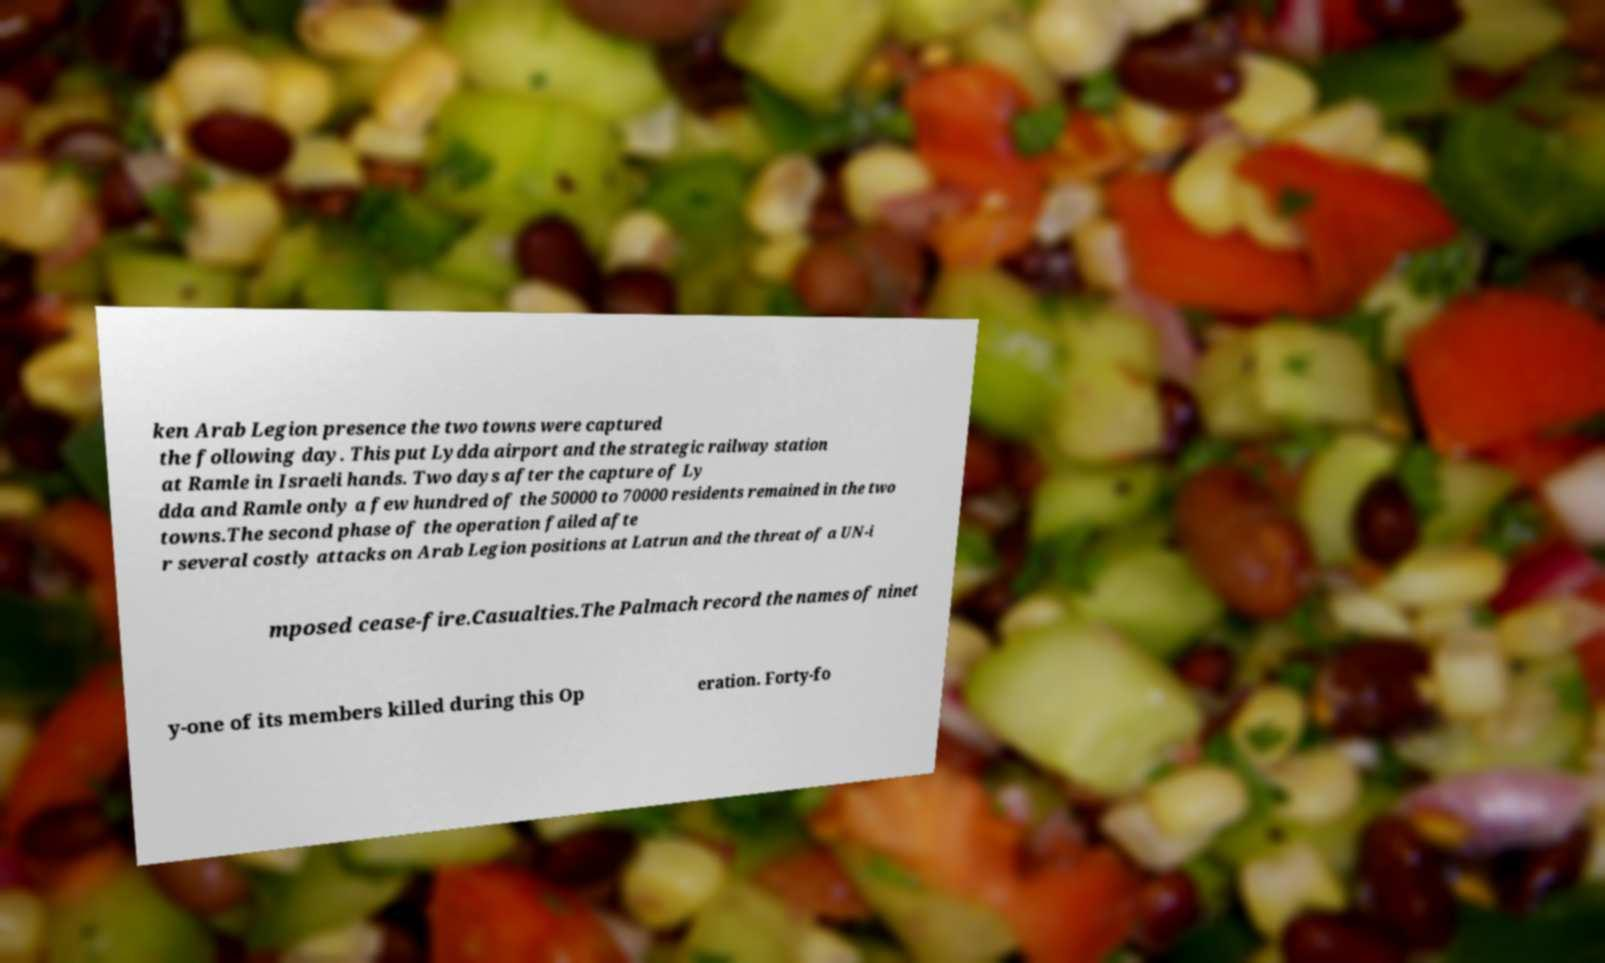There's text embedded in this image that I need extracted. Can you transcribe it verbatim? ken Arab Legion presence the two towns were captured the following day. This put Lydda airport and the strategic railway station at Ramle in Israeli hands. Two days after the capture of Ly dda and Ramle only a few hundred of the 50000 to 70000 residents remained in the two towns.The second phase of the operation failed afte r several costly attacks on Arab Legion positions at Latrun and the threat of a UN-i mposed cease-fire.Casualties.The Palmach record the names of ninet y-one of its members killed during this Op eration. Forty-fo 